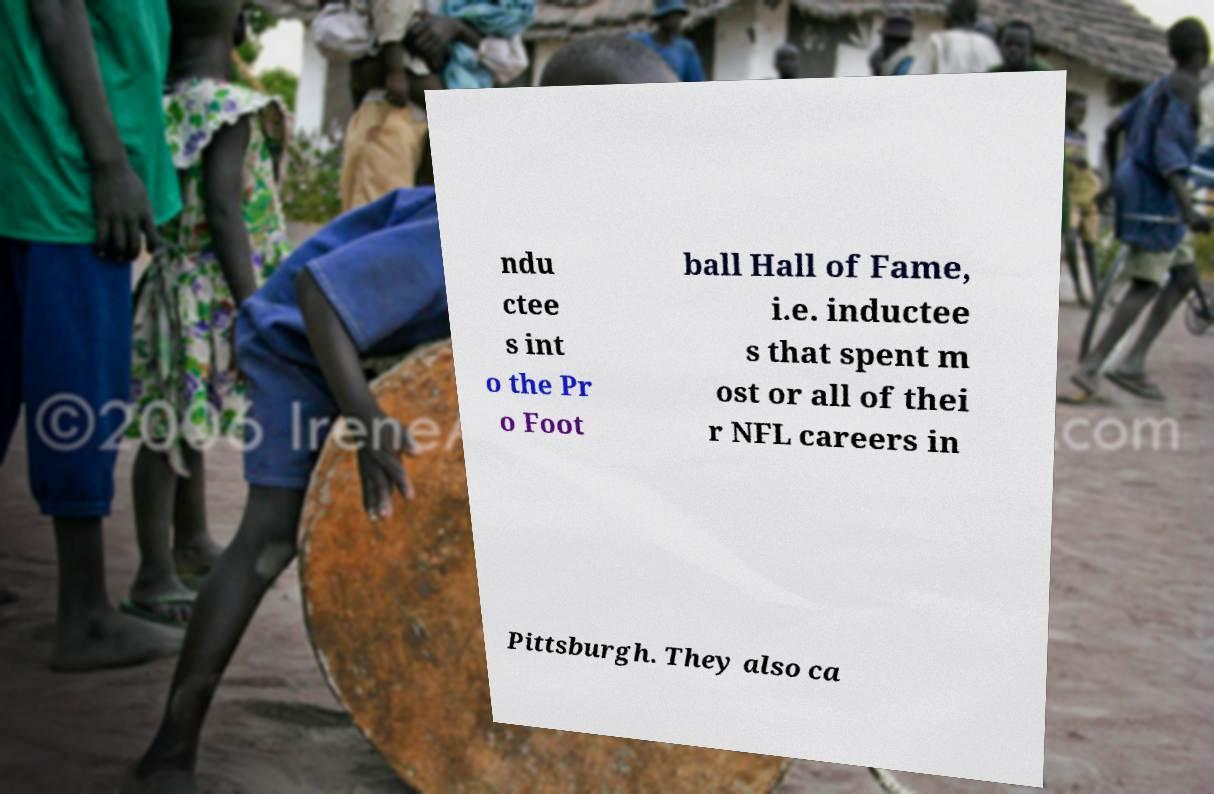Could you extract and type out the text from this image? ndu ctee s int o the Pr o Foot ball Hall of Fame, i.e. inductee s that spent m ost or all of thei r NFL careers in Pittsburgh. They also ca 